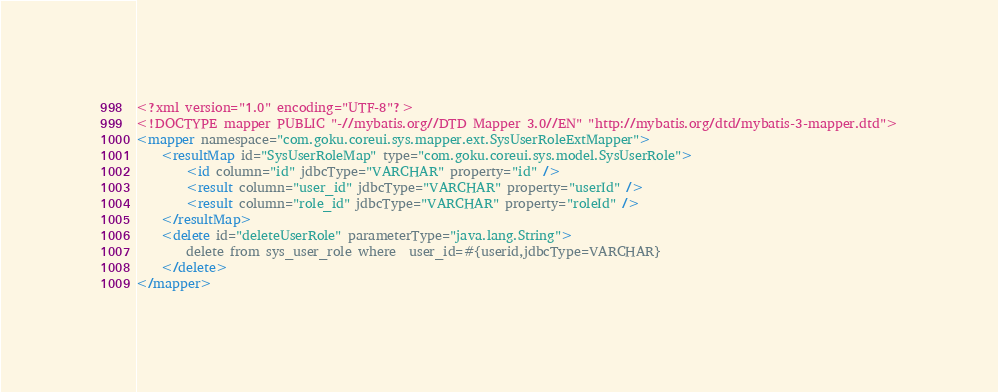<code> <loc_0><loc_0><loc_500><loc_500><_XML_><?xml version="1.0" encoding="UTF-8"?>
<!DOCTYPE mapper PUBLIC "-//mybatis.org//DTD Mapper 3.0//EN" "http://mybatis.org/dtd/mybatis-3-mapper.dtd">
<mapper namespace="com.goku.coreui.sys.mapper.ext.SysUserRoleExtMapper">
    <resultMap id="SysUserRoleMap" type="com.goku.coreui.sys.model.SysUserRole">
        <id column="id" jdbcType="VARCHAR" property="id" />
        <result column="user_id" jdbcType="VARCHAR" property="userId" />
        <result column="role_id" jdbcType="VARCHAR" property="roleId" />
    </resultMap>
    <delete id="deleteUserRole" parameterType="java.lang.String">
        delete from sys_user_role where  user_id=#{userid,jdbcType=VARCHAR}
    </delete>
</mapper></code> 